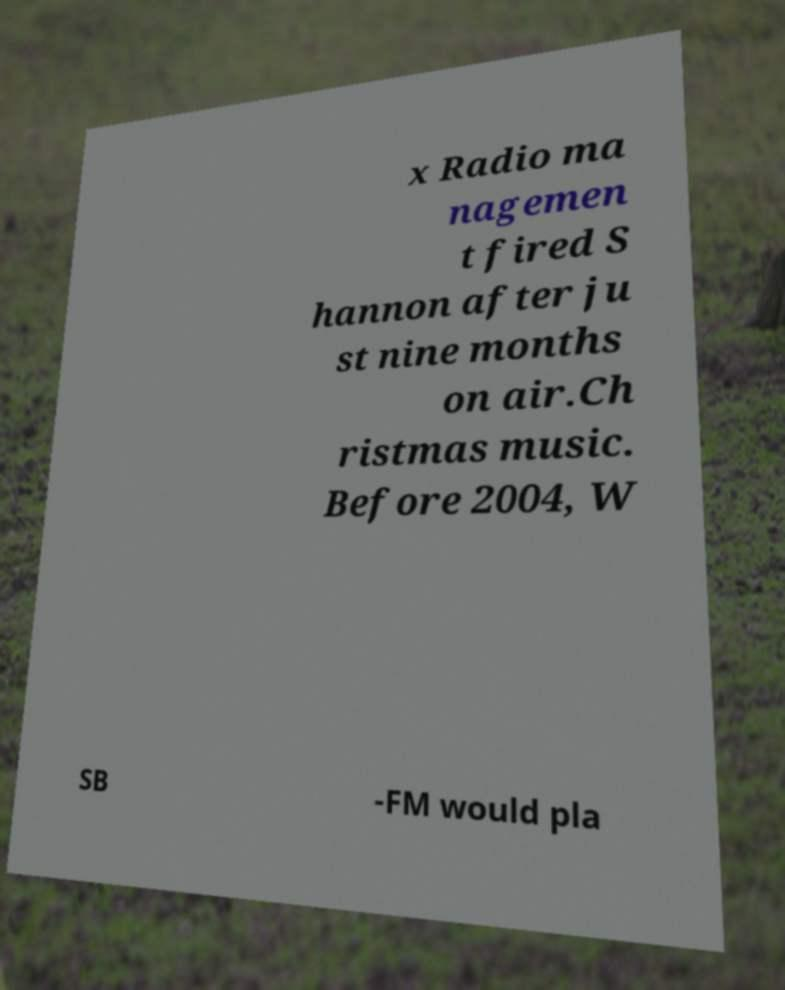Please read and relay the text visible in this image. What does it say? x Radio ma nagemen t fired S hannon after ju st nine months on air.Ch ristmas music. Before 2004, W SB -FM would pla 